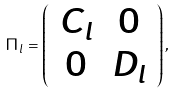<formula> <loc_0><loc_0><loc_500><loc_500>\Pi _ { l } = \left ( \begin{array} { c c } C _ { l } & 0 \\ 0 & D _ { l } \end{array} \right ) ,</formula> 